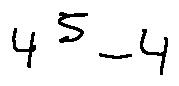Convert formula to latex. <formula><loc_0><loc_0><loc_500><loc_500>4 ^ { 5 } - 4</formula> 